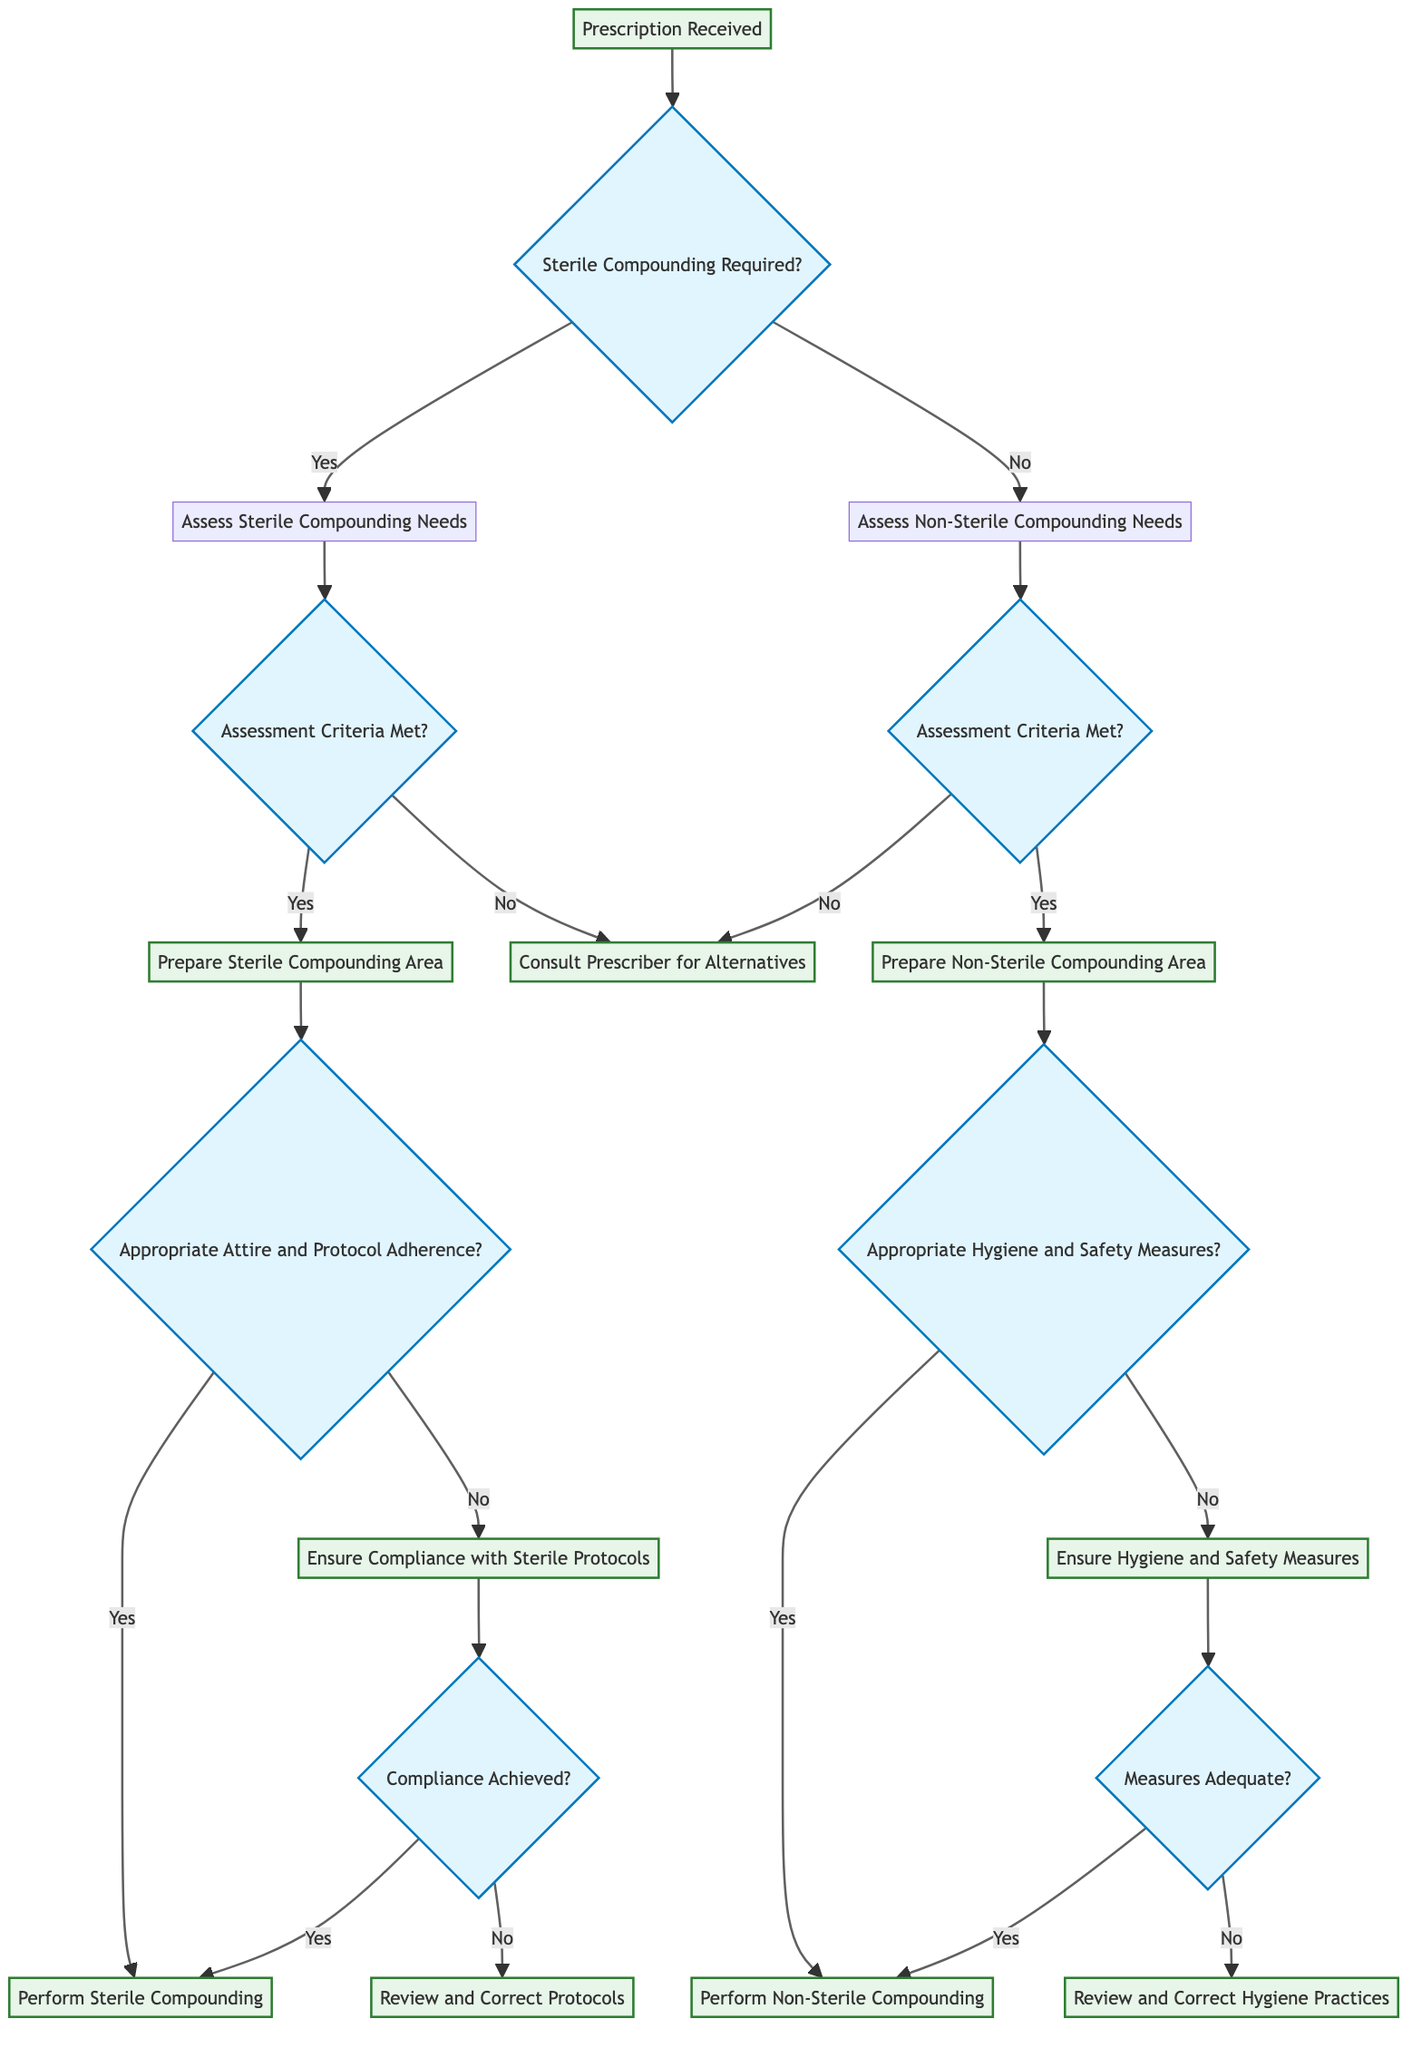What is the first step in the decision tree? The first step shown in the diagram is "Prescription Received." There are no preceding nodes or actions indicated in the diagram, making it the starting point for all subsequent decisions.
Answer: Prescription Received How many main branches are there after the initial node? After the initial node "Prescription Received," there are two main branches based on whether sterile compounding is required: one branch for "Yes" and one for "No." Therefore, there are two main branches following the first step.
Answer: 2 If sterile compounding is required, what is the next question to assess? After determining that sterile compounding is required (Yes branch), the next question in the decision tree is, "Assessment Criteria Met?" This question determines whether to prepare the sterile compounding area or consult the prescriber.
Answer: Assessment Criteria Met? What step follows if the assessment criteria for sterile compounding are not met? If the assessment criteria are not met (No response to "Assessment Criteria Met?"), the next step is to "Consult Prescriber for Alternatives," indicating a need for further decisions before compounding.
Answer: Consult Prescriber for Alternatives What must be ensured before performing non-sterile compounding? Before performing non-sterile compounding, it is essential to ensure "Appropriate Hygiene and Safety Measures." This is crucial for compliance with health standards.
Answer: Appropriate Hygiene and Safety Measures If hygiene and safety measures are inadequate, what is the next action? If the hygiene and safety measures are inadequate (No response to "Appropriate Hygiene and Safety Measures"), the next action is to "Review and Correct Hygiene Practices" to ensure compliance before proceeding with the compounding process.
Answer: Review and Correct Hygiene Practices What action is repeated in both the sterile and non-sterile compounding branches if compliance is not achieved? In both branches, if compliance is not achieved after reviewing protocols, the action repeated is to "Review and Correct Protocols" for sterile compounding or "Review and Correct Hygiene Practices" for non-sterile compounding. This reinforces the importance of compliance in both settings.
Answer: Review and Correct Protocols / Review and Correct Hygiene Practices How many total terminal actions are in the decision tree? The decision tree has four terminal actions: "Perform Sterile Compounding," "Perform Non-Sterile Compounding," "Consult Prescriber for Alternatives," and the reviews for protocols and hygiene practices. Summing these gives a total of six.
Answer: 6 What happens if both assessment criteria for sterile and non-sterile compounding are not met? If both sterile and non-sterile assessments are not met, the outcome leads to "Consult Prescriber for Alternatives," showing the dependency on prescriber input when compounding cannot proceed.
Answer: Consult Prescriber for Alternatives 